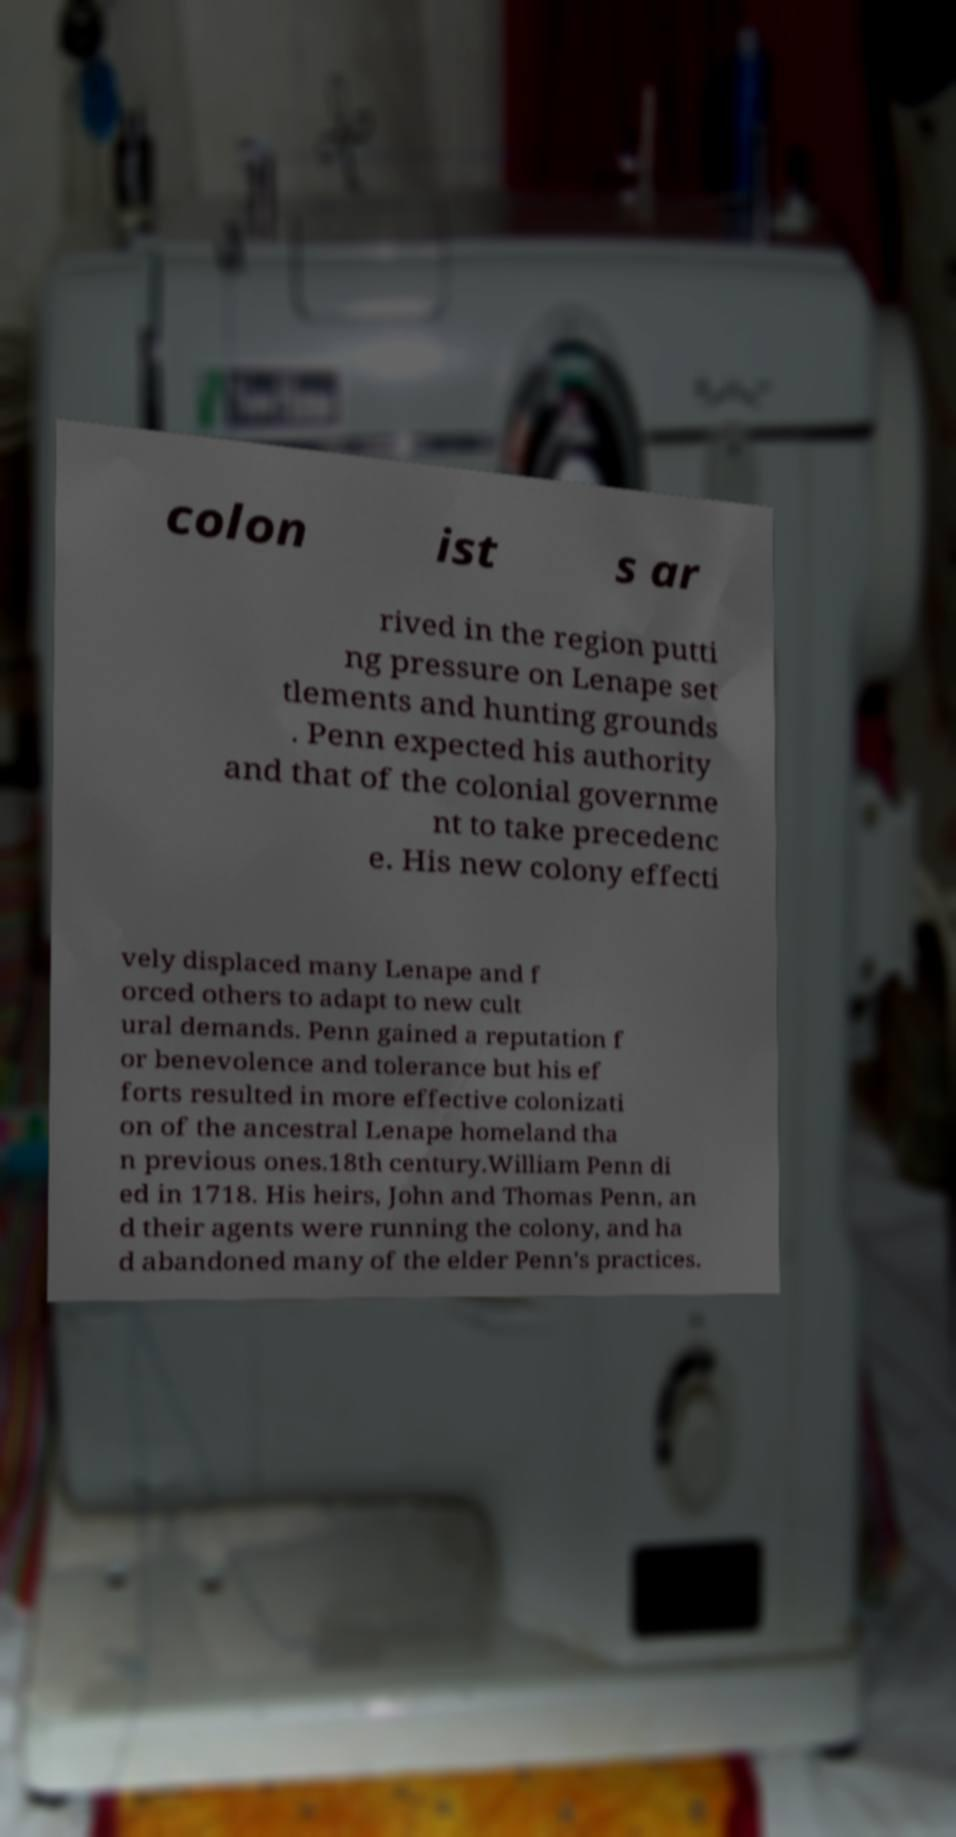Please read and relay the text visible in this image. What does it say? colon ist s ar rived in the region putti ng pressure on Lenape set tlements and hunting grounds . Penn expected his authority and that of the colonial governme nt to take precedenc e. His new colony effecti vely displaced many Lenape and f orced others to adapt to new cult ural demands. Penn gained a reputation f or benevolence and tolerance but his ef forts resulted in more effective colonizati on of the ancestral Lenape homeland tha n previous ones.18th century.William Penn di ed in 1718. His heirs, John and Thomas Penn, an d their agents were running the colony, and ha d abandoned many of the elder Penn's practices. 